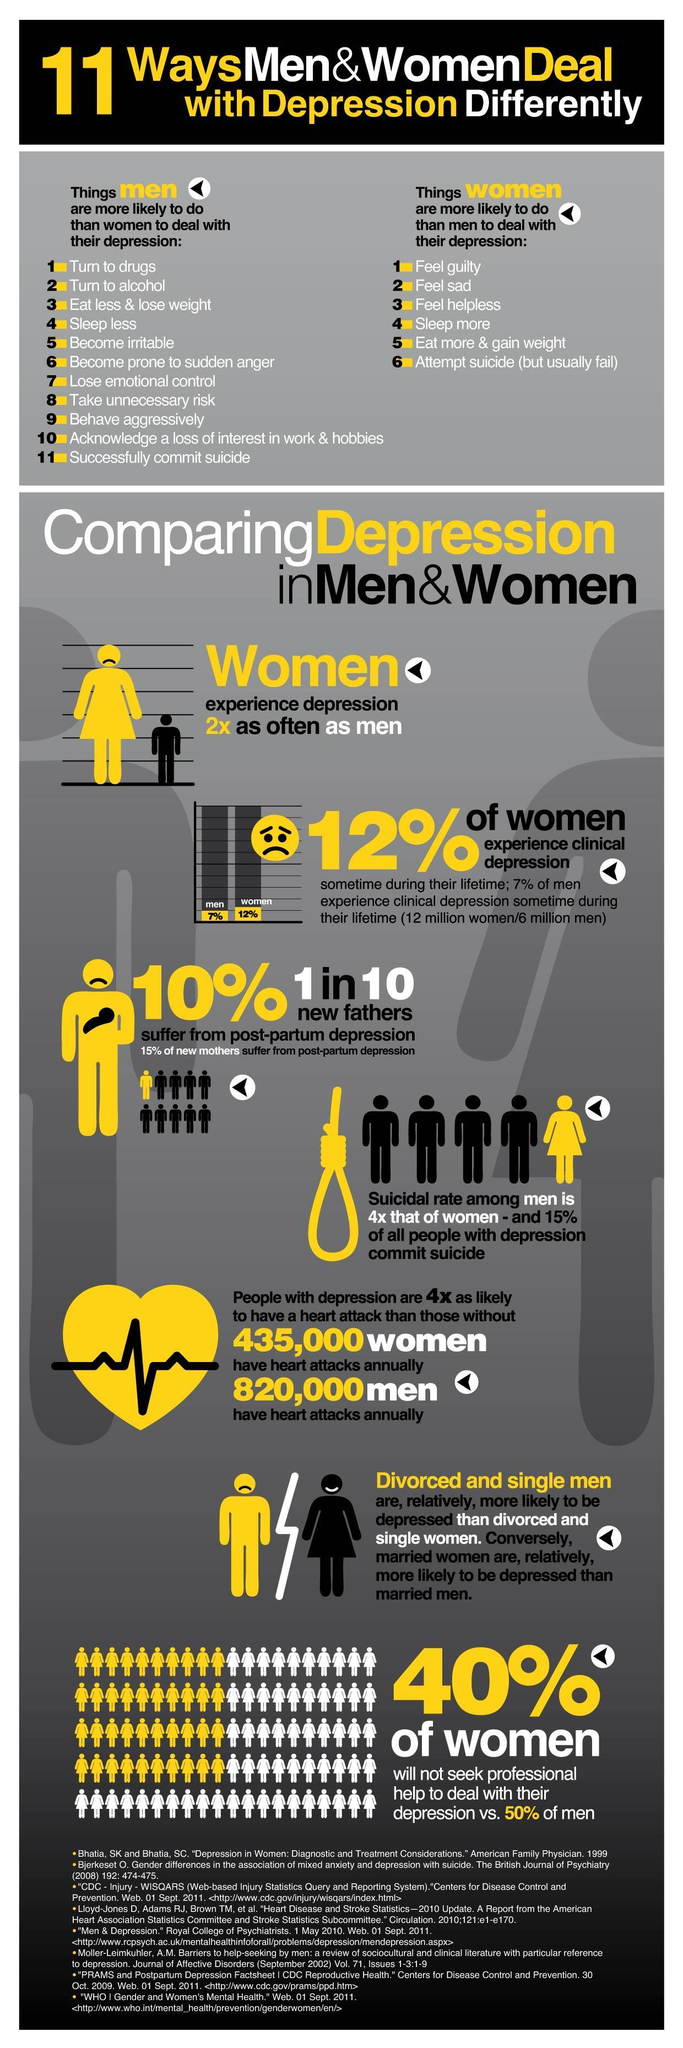What percentage of women seek professional help to deal with their depression?
Answer the question with a short phrase. 60% What percentage of new mothers are not suffering from post-partum depression? 85% What percentage of men have not experienced clinical depression? 93% Out of 10, how many new fathers suffer from post-partum depression? 9 What percentage of women have not experienced clinical depression? 88% 